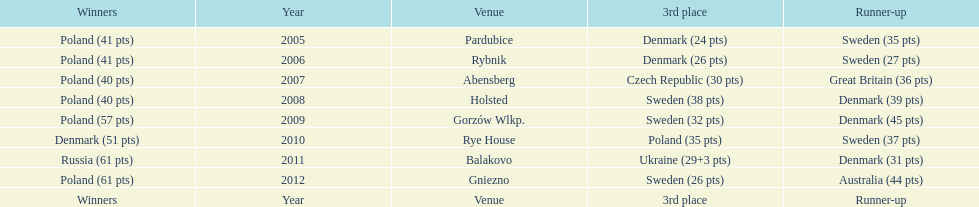Previous to 2008 how many times was sweden the runner up? 2. 